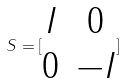<formula> <loc_0><loc_0><loc_500><loc_500>S = [ \begin{matrix} I & 0 \\ 0 & - I \end{matrix} ]</formula> 